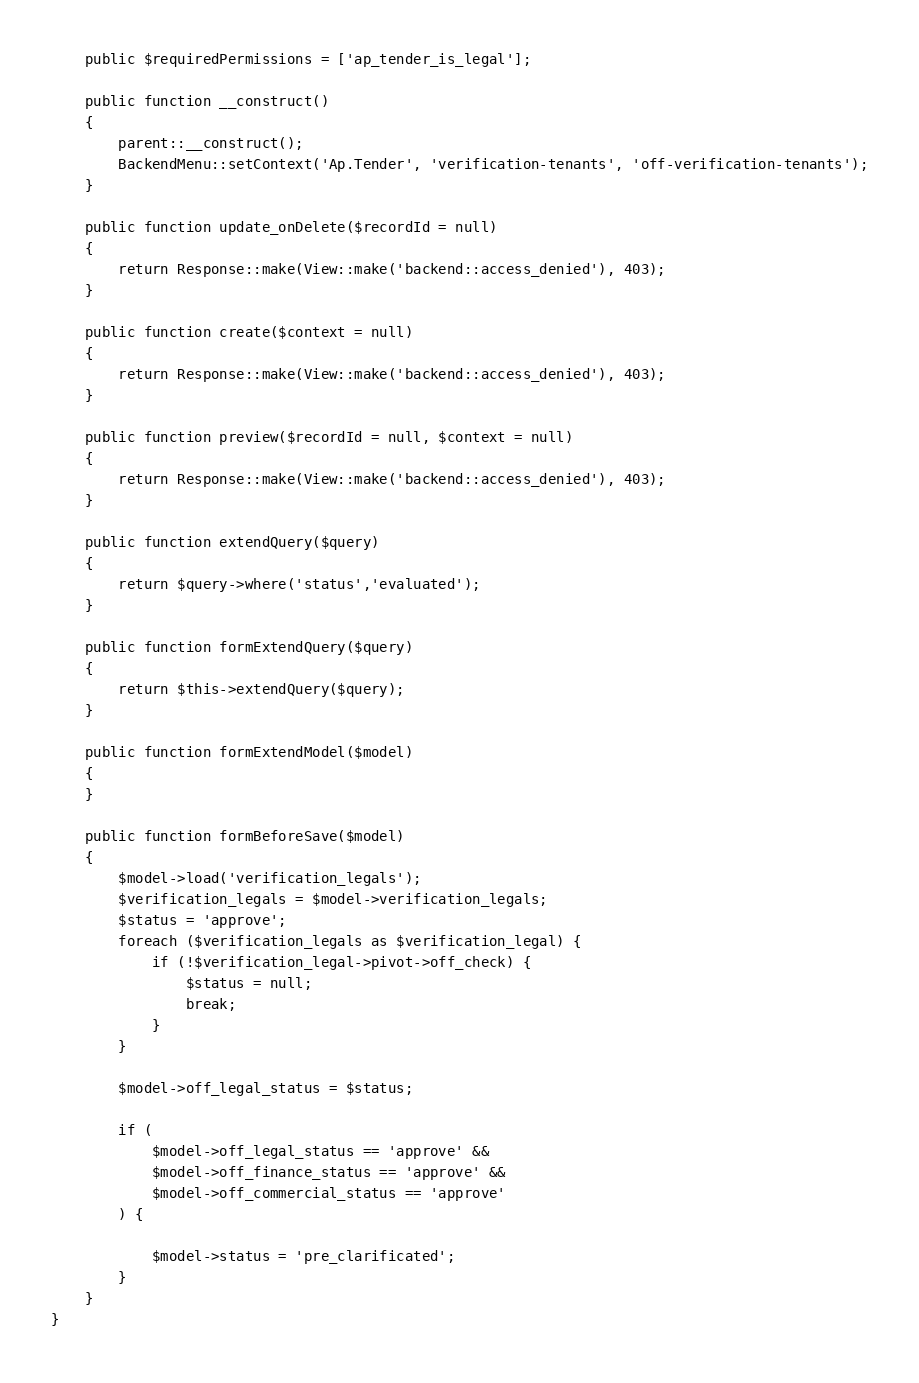<code> <loc_0><loc_0><loc_500><loc_500><_PHP_>
    public $requiredPermissions = ['ap_tender_is_legal'];

    public function __construct()
    {
        parent::__construct();
        BackendMenu::setContext('Ap.Tender', 'verification-tenants', 'off-verification-tenants');
    }

    public function update_onDelete($recordId = null)
    {
        return Response::make(View::make('backend::access_denied'), 403);
    }

    public function create($context = null)
    {
        return Response::make(View::make('backend::access_denied'), 403);
    }

    public function preview($recordId = null, $context = null)
    {
        return Response::make(View::make('backend::access_denied'), 403);
    }

    public function extendQuery($query)
    {
        return $query->where('status','evaluated');
    }

    public function formExtendQuery($query)
    {
        return $this->extendQuery($query);
    }

    public function formExtendModel($model)
    {
    }

    public function formBeforeSave($model)
    {
        $model->load('verification_legals');
        $verification_legals = $model->verification_legals;
        $status = 'approve';
        foreach ($verification_legals as $verification_legal) {
            if (!$verification_legal->pivot->off_check) {
                $status = null;
                break;
            }
        }

        $model->off_legal_status = $status;

        if (
            $model->off_legal_status == 'approve' &&
            $model->off_finance_status == 'approve' &&
            $model->off_commercial_status == 'approve'
        ) {

            $model->status = 'pre_clarificated';
        }
    }
}
</code> 